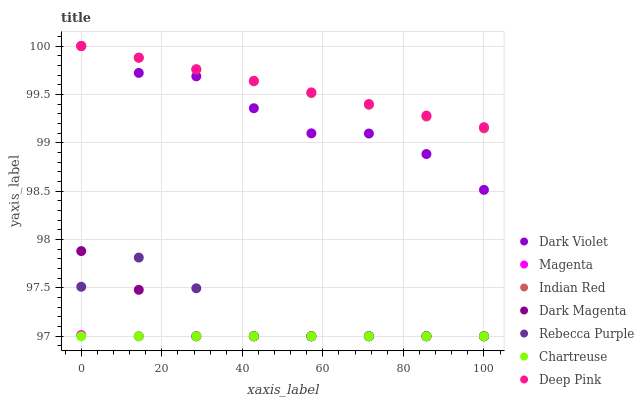Does Chartreuse have the minimum area under the curve?
Answer yes or no. Yes. Does Deep Pink have the maximum area under the curve?
Answer yes or no. Yes. Does Dark Magenta have the minimum area under the curve?
Answer yes or no. No. Does Dark Magenta have the maximum area under the curve?
Answer yes or no. No. Is Chartreuse the smoothest?
Answer yes or no. Yes. Is Rebecca Purple the roughest?
Answer yes or no. Yes. Is Dark Magenta the smoothest?
Answer yes or no. No. Is Dark Magenta the roughest?
Answer yes or no. No. Does Dark Magenta have the lowest value?
Answer yes or no. Yes. Does Dark Violet have the lowest value?
Answer yes or no. No. Does Indian Red have the highest value?
Answer yes or no. Yes. Does Dark Magenta have the highest value?
Answer yes or no. No. Is Chartreuse less than Dark Violet?
Answer yes or no. Yes. Is Indian Red greater than Magenta?
Answer yes or no. Yes. Does Rebecca Purple intersect Magenta?
Answer yes or no. Yes. Is Rebecca Purple less than Magenta?
Answer yes or no. No. Is Rebecca Purple greater than Magenta?
Answer yes or no. No. Does Chartreuse intersect Dark Violet?
Answer yes or no. No. 